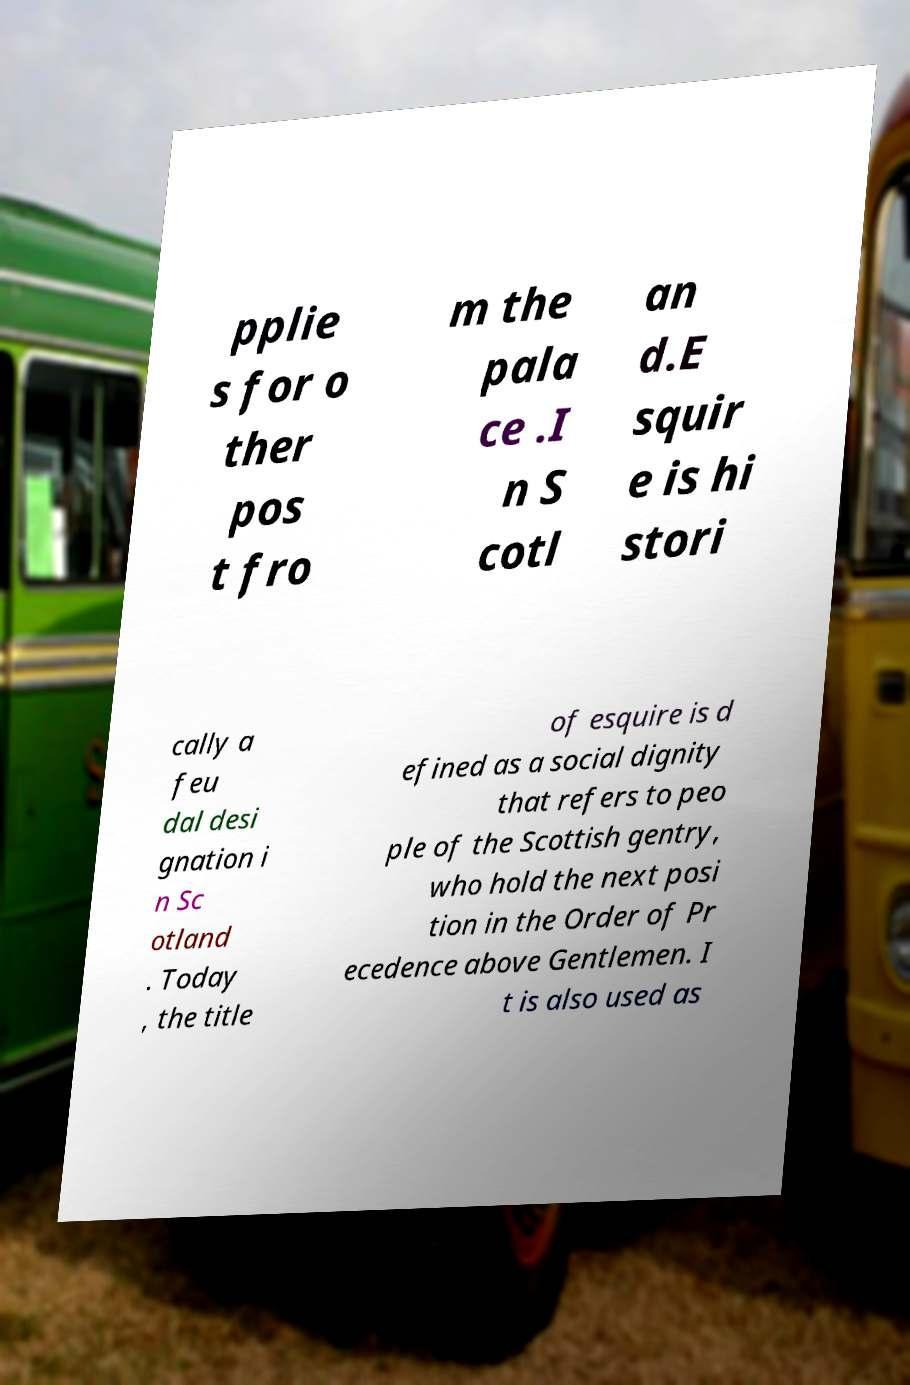What messages or text are displayed in this image? I need them in a readable, typed format. pplie s for o ther pos t fro m the pala ce .I n S cotl an d.E squir e is hi stori cally a feu dal desi gnation i n Sc otland . Today , the title of esquire is d efined as a social dignity that refers to peo ple of the Scottish gentry, who hold the next posi tion in the Order of Pr ecedence above Gentlemen. I t is also used as 